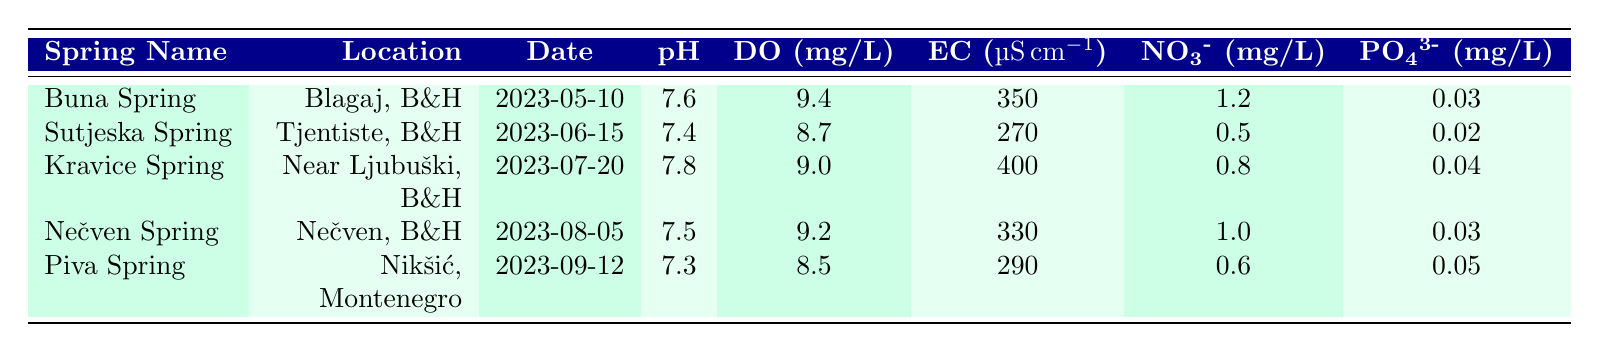What is the pH level of the Buna Spring? The pH level of Buna Spring can be found in the table under the pH column for the row corresponding to Buna Spring, which shows a value of 7.6.
Answer: 7.6 Which spring has the highest electrical conductivity? To find the spring with the highest electrical conductivity, I compare the values in the Electrical Conductivity column. Kravice Spring has a value of 400, which is higher than all other springs listed.
Answer: Kravice Spring Is the nitrate level in Sutjeska Spring greater than 1 mg/L? Looking at the Nitrate column for Sutjeska Spring, the value is 0.5 mg/L, which is less than 1 mg/L.
Answer: No What is the average temperature of the springs measured? I calculate the average temperature by adding all temperatures together: (12.1 + 11.5 + 13.0 + 12.5 + 10.8) = 60.9, and then divide by the number of springs, which is 5. Thus, the average temperature is 60.9 / 5 = 12.18.
Answer: 12.18 Which spring has the lowest dissolved oxygen level? To find the lowest dissolved oxygen level, I look through the Dissolved Oxygen column. Piva Spring has a value of 8.5 mg/L, which is lower than the values for the other springs.
Answer: Piva Spring Are all spring measurements taken in 2023? I check the Date Measured column for each spring and confirm that all dates listed are in the year 2023.
Answer: Yes What is the difference in phosphate levels between Kravice Spring and Piva Spring? I subtract the phosphate level of Piva Spring (0.05 mg/L) from the level of Kravice Spring (0.04 mg/L). The difference is 0.04 - 0.05 = -0.01 mg/L, indicating that Piva Spring has a higher level.
Answer: -0.01 mg/L What is the spring with the highest dissolved oxygen and what is that level? I look at the Dissolved Oxygen column and find that Buna Spring has the highest level at 9.4 mg/L.
Answer: Buna Spring, 9.4 mg/L 